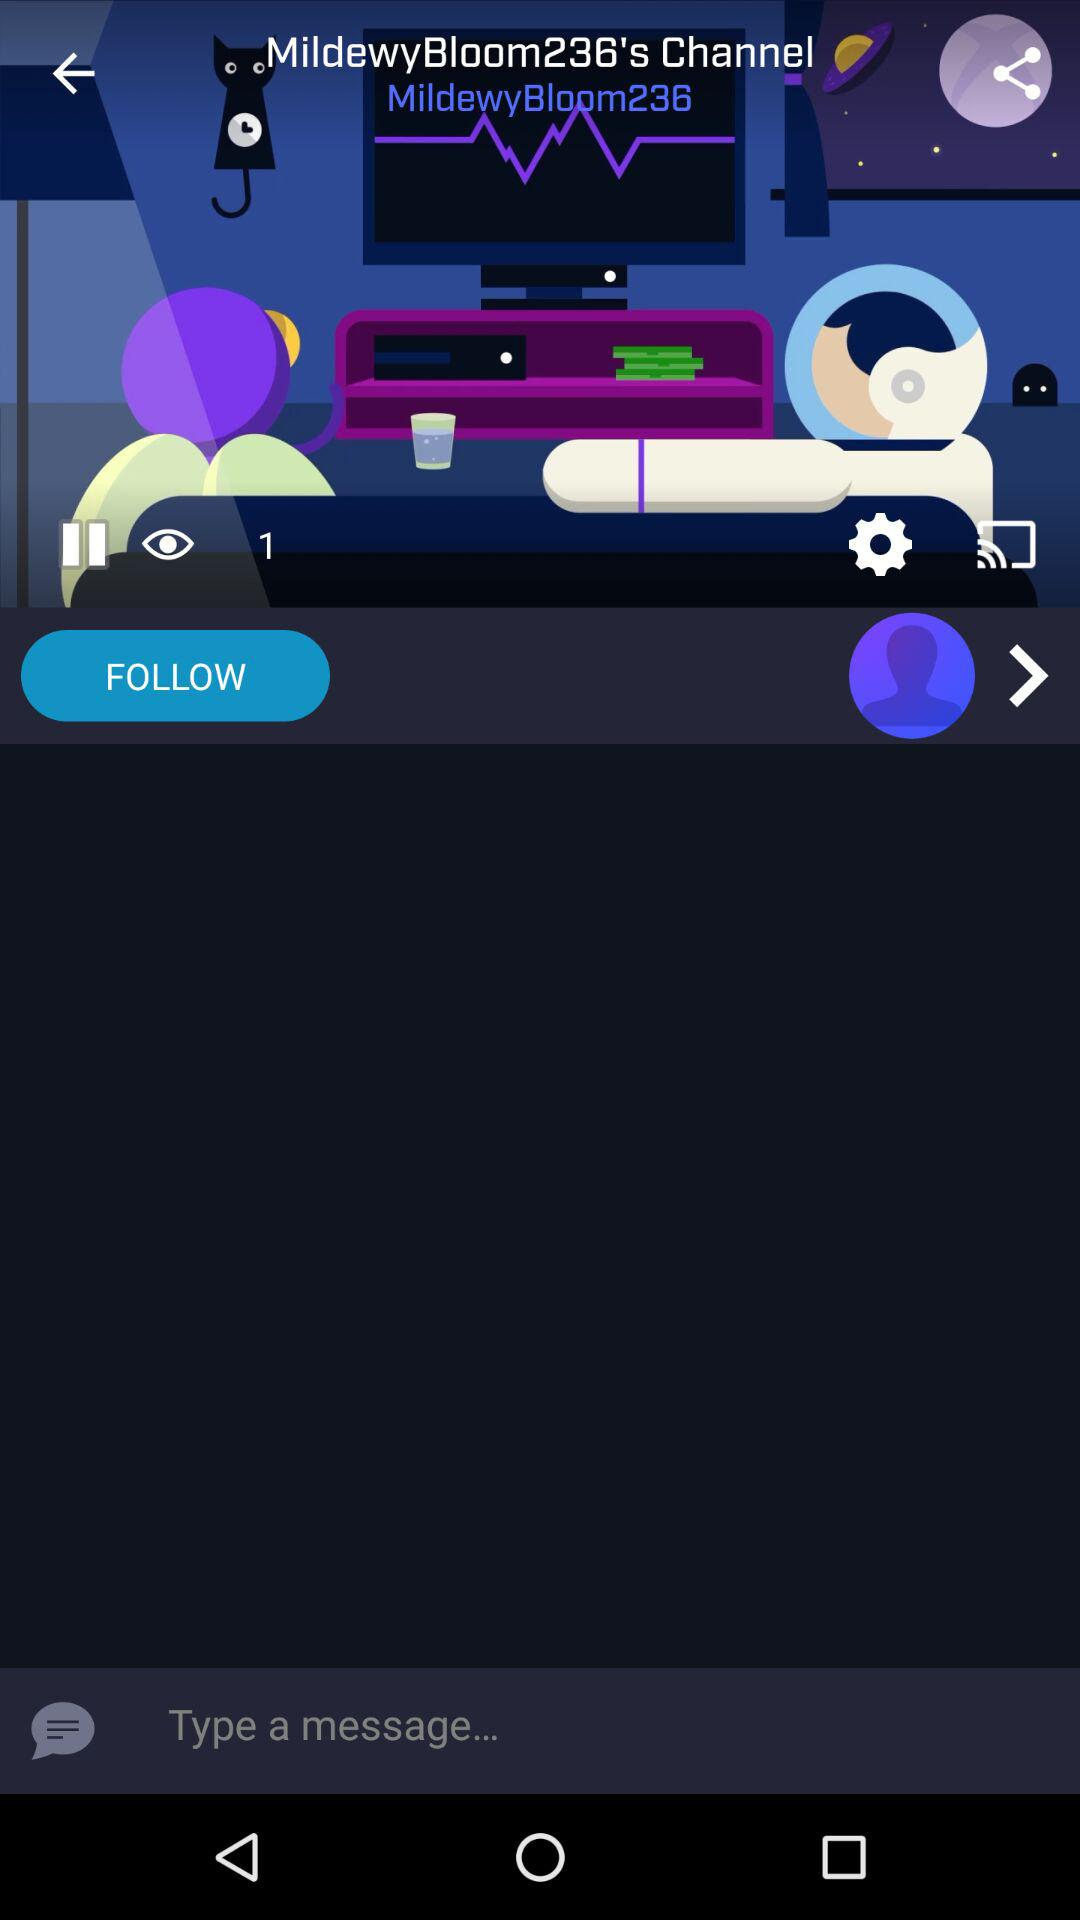How many followers are there?
When the provided information is insufficient, respond with <no answer>. <no answer> 